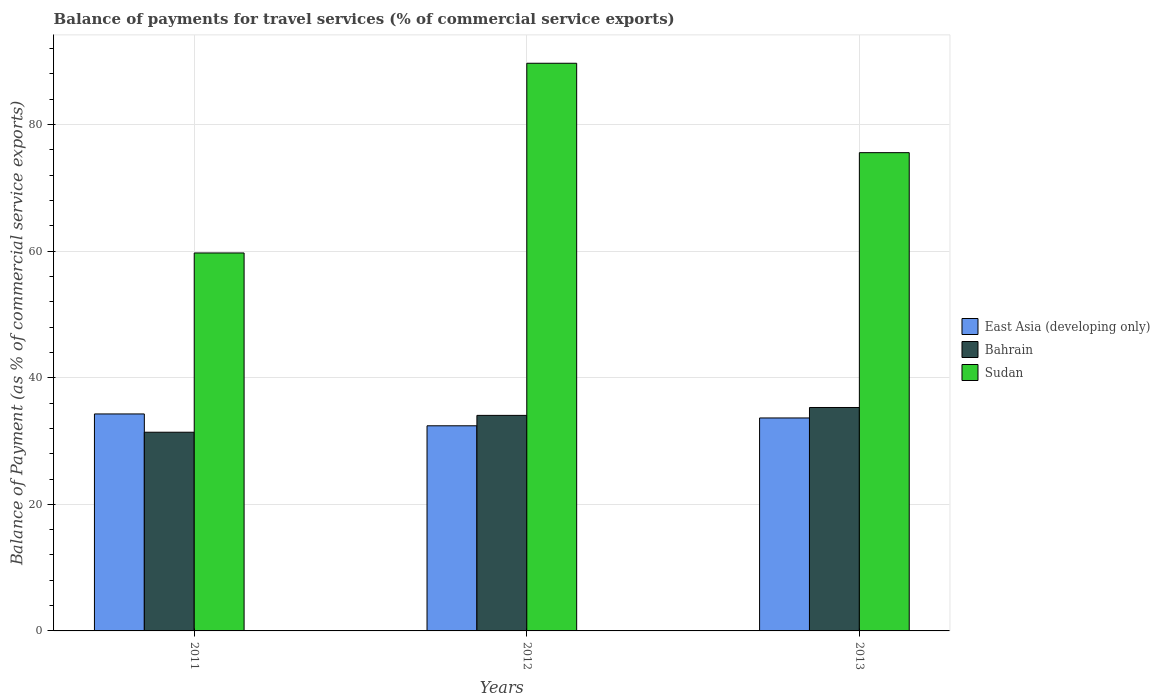Are the number of bars on each tick of the X-axis equal?
Your response must be concise. Yes. How many bars are there on the 2nd tick from the left?
Your response must be concise. 3. How many bars are there on the 2nd tick from the right?
Offer a very short reply. 3. What is the label of the 3rd group of bars from the left?
Provide a succinct answer. 2013. In how many cases, is the number of bars for a given year not equal to the number of legend labels?
Your answer should be compact. 0. What is the balance of payments for travel services in East Asia (developing only) in 2013?
Your answer should be very brief. 33.64. Across all years, what is the maximum balance of payments for travel services in Bahrain?
Provide a short and direct response. 35.3. Across all years, what is the minimum balance of payments for travel services in East Asia (developing only)?
Keep it short and to the point. 32.41. What is the total balance of payments for travel services in East Asia (developing only) in the graph?
Provide a succinct answer. 100.33. What is the difference between the balance of payments for travel services in East Asia (developing only) in 2011 and that in 2012?
Offer a terse response. 1.87. What is the difference between the balance of payments for travel services in Sudan in 2011 and the balance of payments for travel services in Bahrain in 2013?
Make the answer very short. 24.41. What is the average balance of payments for travel services in Bahrain per year?
Offer a terse response. 33.58. In the year 2013, what is the difference between the balance of payments for travel services in Sudan and balance of payments for travel services in East Asia (developing only)?
Offer a terse response. 41.91. In how many years, is the balance of payments for travel services in Sudan greater than 44 %?
Make the answer very short. 3. What is the ratio of the balance of payments for travel services in Bahrain in 2012 to that in 2013?
Make the answer very short. 0.96. Is the balance of payments for travel services in Sudan in 2012 less than that in 2013?
Make the answer very short. No. Is the difference between the balance of payments for travel services in Sudan in 2011 and 2013 greater than the difference between the balance of payments for travel services in East Asia (developing only) in 2011 and 2013?
Offer a very short reply. No. What is the difference between the highest and the second highest balance of payments for travel services in Bahrain?
Keep it short and to the point. 1.25. What is the difference between the highest and the lowest balance of payments for travel services in Bahrain?
Your answer should be compact. 3.91. What does the 1st bar from the left in 2013 represents?
Your answer should be compact. East Asia (developing only). What does the 1st bar from the right in 2013 represents?
Your answer should be very brief. Sudan. Is it the case that in every year, the sum of the balance of payments for travel services in Sudan and balance of payments for travel services in Bahrain is greater than the balance of payments for travel services in East Asia (developing only)?
Offer a very short reply. Yes. How many years are there in the graph?
Offer a very short reply. 3. What is the difference between two consecutive major ticks on the Y-axis?
Ensure brevity in your answer.  20. Are the values on the major ticks of Y-axis written in scientific E-notation?
Give a very brief answer. No. How many legend labels are there?
Give a very brief answer. 3. What is the title of the graph?
Provide a succinct answer. Balance of payments for travel services (% of commercial service exports). What is the label or title of the X-axis?
Your answer should be compact. Years. What is the label or title of the Y-axis?
Your response must be concise. Balance of Payment (as % of commercial service exports). What is the Balance of Payment (as % of commercial service exports) in East Asia (developing only) in 2011?
Keep it short and to the point. 34.28. What is the Balance of Payment (as % of commercial service exports) in Bahrain in 2011?
Keep it short and to the point. 31.39. What is the Balance of Payment (as % of commercial service exports) in Sudan in 2011?
Provide a succinct answer. 59.71. What is the Balance of Payment (as % of commercial service exports) of East Asia (developing only) in 2012?
Your answer should be very brief. 32.41. What is the Balance of Payment (as % of commercial service exports) in Bahrain in 2012?
Make the answer very short. 34.05. What is the Balance of Payment (as % of commercial service exports) of Sudan in 2012?
Your answer should be compact. 89.68. What is the Balance of Payment (as % of commercial service exports) in East Asia (developing only) in 2013?
Provide a succinct answer. 33.64. What is the Balance of Payment (as % of commercial service exports) in Bahrain in 2013?
Offer a terse response. 35.3. What is the Balance of Payment (as % of commercial service exports) of Sudan in 2013?
Your answer should be very brief. 75.56. Across all years, what is the maximum Balance of Payment (as % of commercial service exports) of East Asia (developing only)?
Keep it short and to the point. 34.28. Across all years, what is the maximum Balance of Payment (as % of commercial service exports) in Bahrain?
Provide a short and direct response. 35.3. Across all years, what is the maximum Balance of Payment (as % of commercial service exports) of Sudan?
Your response must be concise. 89.68. Across all years, what is the minimum Balance of Payment (as % of commercial service exports) in East Asia (developing only)?
Provide a short and direct response. 32.41. Across all years, what is the minimum Balance of Payment (as % of commercial service exports) in Bahrain?
Your response must be concise. 31.39. Across all years, what is the minimum Balance of Payment (as % of commercial service exports) in Sudan?
Your response must be concise. 59.71. What is the total Balance of Payment (as % of commercial service exports) in East Asia (developing only) in the graph?
Keep it short and to the point. 100.33. What is the total Balance of Payment (as % of commercial service exports) of Bahrain in the graph?
Your answer should be compact. 100.74. What is the total Balance of Payment (as % of commercial service exports) of Sudan in the graph?
Your response must be concise. 224.95. What is the difference between the Balance of Payment (as % of commercial service exports) in East Asia (developing only) in 2011 and that in 2012?
Give a very brief answer. 1.87. What is the difference between the Balance of Payment (as % of commercial service exports) of Bahrain in 2011 and that in 2012?
Give a very brief answer. -2.66. What is the difference between the Balance of Payment (as % of commercial service exports) of Sudan in 2011 and that in 2012?
Offer a very short reply. -29.97. What is the difference between the Balance of Payment (as % of commercial service exports) of East Asia (developing only) in 2011 and that in 2013?
Provide a succinct answer. 0.63. What is the difference between the Balance of Payment (as % of commercial service exports) in Bahrain in 2011 and that in 2013?
Your response must be concise. -3.91. What is the difference between the Balance of Payment (as % of commercial service exports) in Sudan in 2011 and that in 2013?
Your answer should be compact. -15.84. What is the difference between the Balance of Payment (as % of commercial service exports) of East Asia (developing only) in 2012 and that in 2013?
Offer a very short reply. -1.24. What is the difference between the Balance of Payment (as % of commercial service exports) of Bahrain in 2012 and that in 2013?
Make the answer very short. -1.25. What is the difference between the Balance of Payment (as % of commercial service exports) of Sudan in 2012 and that in 2013?
Provide a short and direct response. 14.12. What is the difference between the Balance of Payment (as % of commercial service exports) of East Asia (developing only) in 2011 and the Balance of Payment (as % of commercial service exports) of Bahrain in 2012?
Keep it short and to the point. 0.23. What is the difference between the Balance of Payment (as % of commercial service exports) of East Asia (developing only) in 2011 and the Balance of Payment (as % of commercial service exports) of Sudan in 2012?
Provide a short and direct response. -55.4. What is the difference between the Balance of Payment (as % of commercial service exports) in Bahrain in 2011 and the Balance of Payment (as % of commercial service exports) in Sudan in 2012?
Ensure brevity in your answer.  -58.29. What is the difference between the Balance of Payment (as % of commercial service exports) in East Asia (developing only) in 2011 and the Balance of Payment (as % of commercial service exports) in Bahrain in 2013?
Keep it short and to the point. -1.02. What is the difference between the Balance of Payment (as % of commercial service exports) of East Asia (developing only) in 2011 and the Balance of Payment (as % of commercial service exports) of Sudan in 2013?
Provide a succinct answer. -41.28. What is the difference between the Balance of Payment (as % of commercial service exports) of Bahrain in 2011 and the Balance of Payment (as % of commercial service exports) of Sudan in 2013?
Offer a terse response. -44.17. What is the difference between the Balance of Payment (as % of commercial service exports) of East Asia (developing only) in 2012 and the Balance of Payment (as % of commercial service exports) of Bahrain in 2013?
Give a very brief answer. -2.89. What is the difference between the Balance of Payment (as % of commercial service exports) of East Asia (developing only) in 2012 and the Balance of Payment (as % of commercial service exports) of Sudan in 2013?
Give a very brief answer. -43.15. What is the difference between the Balance of Payment (as % of commercial service exports) in Bahrain in 2012 and the Balance of Payment (as % of commercial service exports) in Sudan in 2013?
Your answer should be compact. -41.5. What is the average Balance of Payment (as % of commercial service exports) in East Asia (developing only) per year?
Your answer should be compact. 33.44. What is the average Balance of Payment (as % of commercial service exports) of Bahrain per year?
Offer a terse response. 33.58. What is the average Balance of Payment (as % of commercial service exports) in Sudan per year?
Give a very brief answer. 74.98. In the year 2011, what is the difference between the Balance of Payment (as % of commercial service exports) in East Asia (developing only) and Balance of Payment (as % of commercial service exports) in Bahrain?
Offer a terse response. 2.89. In the year 2011, what is the difference between the Balance of Payment (as % of commercial service exports) of East Asia (developing only) and Balance of Payment (as % of commercial service exports) of Sudan?
Give a very brief answer. -25.43. In the year 2011, what is the difference between the Balance of Payment (as % of commercial service exports) of Bahrain and Balance of Payment (as % of commercial service exports) of Sudan?
Make the answer very short. -28.32. In the year 2012, what is the difference between the Balance of Payment (as % of commercial service exports) in East Asia (developing only) and Balance of Payment (as % of commercial service exports) in Bahrain?
Provide a short and direct response. -1.64. In the year 2012, what is the difference between the Balance of Payment (as % of commercial service exports) of East Asia (developing only) and Balance of Payment (as % of commercial service exports) of Sudan?
Your response must be concise. -57.27. In the year 2012, what is the difference between the Balance of Payment (as % of commercial service exports) in Bahrain and Balance of Payment (as % of commercial service exports) in Sudan?
Provide a short and direct response. -55.63. In the year 2013, what is the difference between the Balance of Payment (as % of commercial service exports) of East Asia (developing only) and Balance of Payment (as % of commercial service exports) of Bahrain?
Offer a terse response. -1.66. In the year 2013, what is the difference between the Balance of Payment (as % of commercial service exports) in East Asia (developing only) and Balance of Payment (as % of commercial service exports) in Sudan?
Offer a very short reply. -41.91. In the year 2013, what is the difference between the Balance of Payment (as % of commercial service exports) in Bahrain and Balance of Payment (as % of commercial service exports) in Sudan?
Give a very brief answer. -40.26. What is the ratio of the Balance of Payment (as % of commercial service exports) of East Asia (developing only) in 2011 to that in 2012?
Ensure brevity in your answer.  1.06. What is the ratio of the Balance of Payment (as % of commercial service exports) in Bahrain in 2011 to that in 2012?
Offer a terse response. 0.92. What is the ratio of the Balance of Payment (as % of commercial service exports) in Sudan in 2011 to that in 2012?
Your answer should be very brief. 0.67. What is the ratio of the Balance of Payment (as % of commercial service exports) of East Asia (developing only) in 2011 to that in 2013?
Offer a very short reply. 1.02. What is the ratio of the Balance of Payment (as % of commercial service exports) of Bahrain in 2011 to that in 2013?
Give a very brief answer. 0.89. What is the ratio of the Balance of Payment (as % of commercial service exports) in Sudan in 2011 to that in 2013?
Provide a short and direct response. 0.79. What is the ratio of the Balance of Payment (as % of commercial service exports) of East Asia (developing only) in 2012 to that in 2013?
Your response must be concise. 0.96. What is the ratio of the Balance of Payment (as % of commercial service exports) in Bahrain in 2012 to that in 2013?
Ensure brevity in your answer.  0.96. What is the ratio of the Balance of Payment (as % of commercial service exports) in Sudan in 2012 to that in 2013?
Provide a succinct answer. 1.19. What is the difference between the highest and the second highest Balance of Payment (as % of commercial service exports) in East Asia (developing only)?
Keep it short and to the point. 0.63. What is the difference between the highest and the second highest Balance of Payment (as % of commercial service exports) of Bahrain?
Make the answer very short. 1.25. What is the difference between the highest and the second highest Balance of Payment (as % of commercial service exports) of Sudan?
Your response must be concise. 14.12. What is the difference between the highest and the lowest Balance of Payment (as % of commercial service exports) of East Asia (developing only)?
Make the answer very short. 1.87. What is the difference between the highest and the lowest Balance of Payment (as % of commercial service exports) of Bahrain?
Your answer should be very brief. 3.91. What is the difference between the highest and the lowest Balance of Payment (as % of commercial service exports) of Sudan?
Keep it short and to the point. 29.97. 